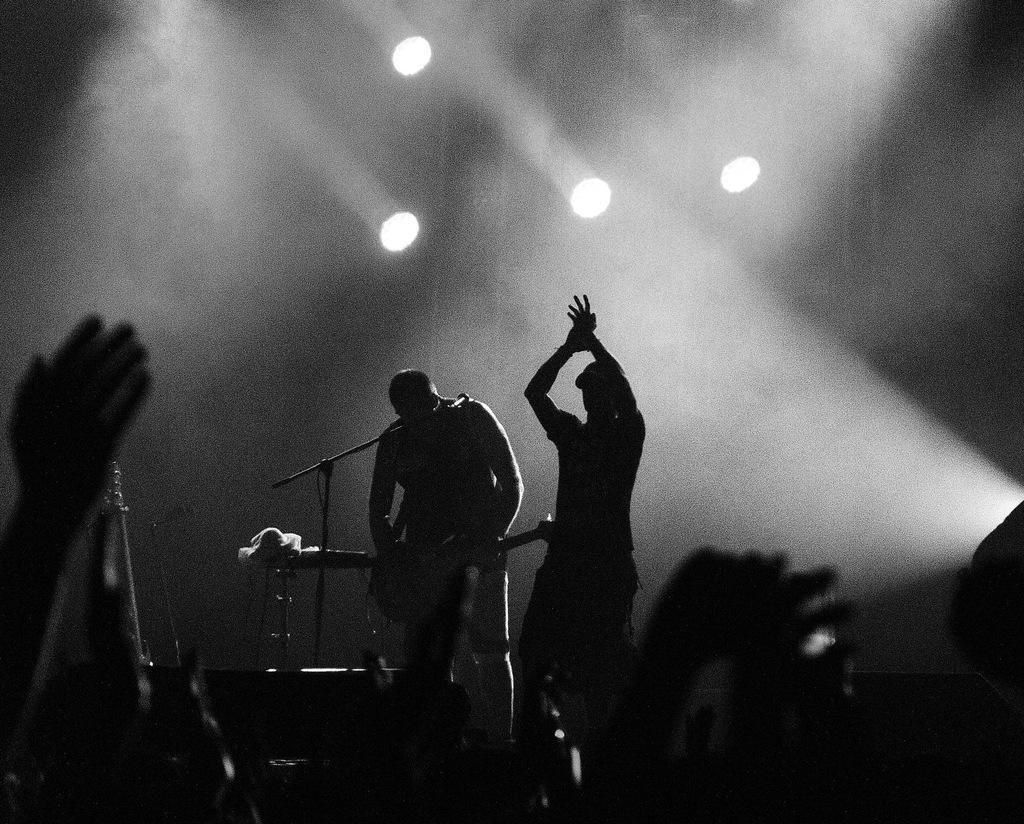Could you give a brief overview of what you see in this image? In this image I can see two persons standing playing some musical instruments. I can also see few lights and the image is in black and white. 